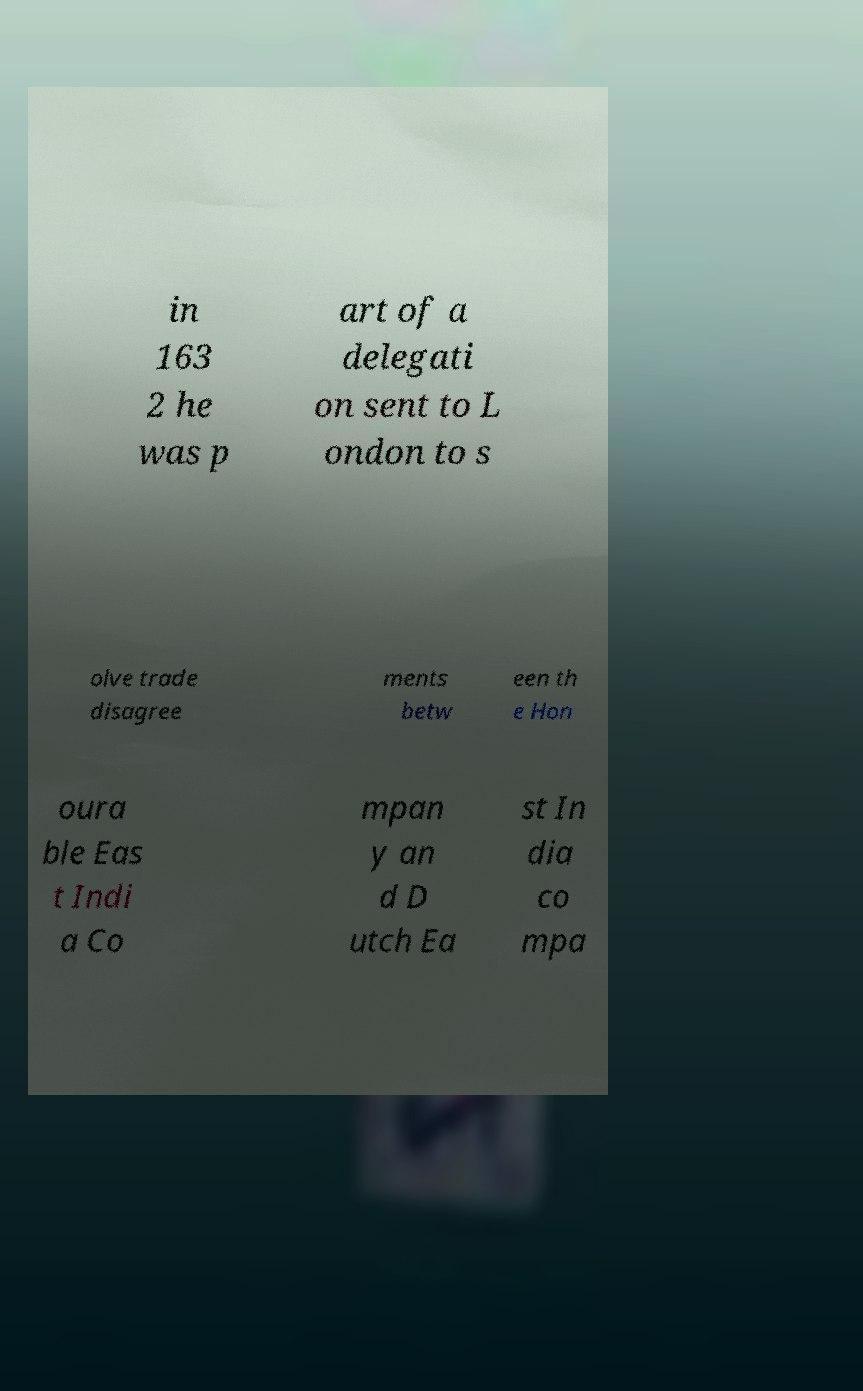There's text embedded in this image that I need extracted. Can you transcribe it verbatim? in 163 2 he was p art of a delegati on sent to L ondon to s olve trade disagree ments betw een th e Hon oura ble Eas t Indi a Co mpan y an d D utch Ea st In dia co mpa 